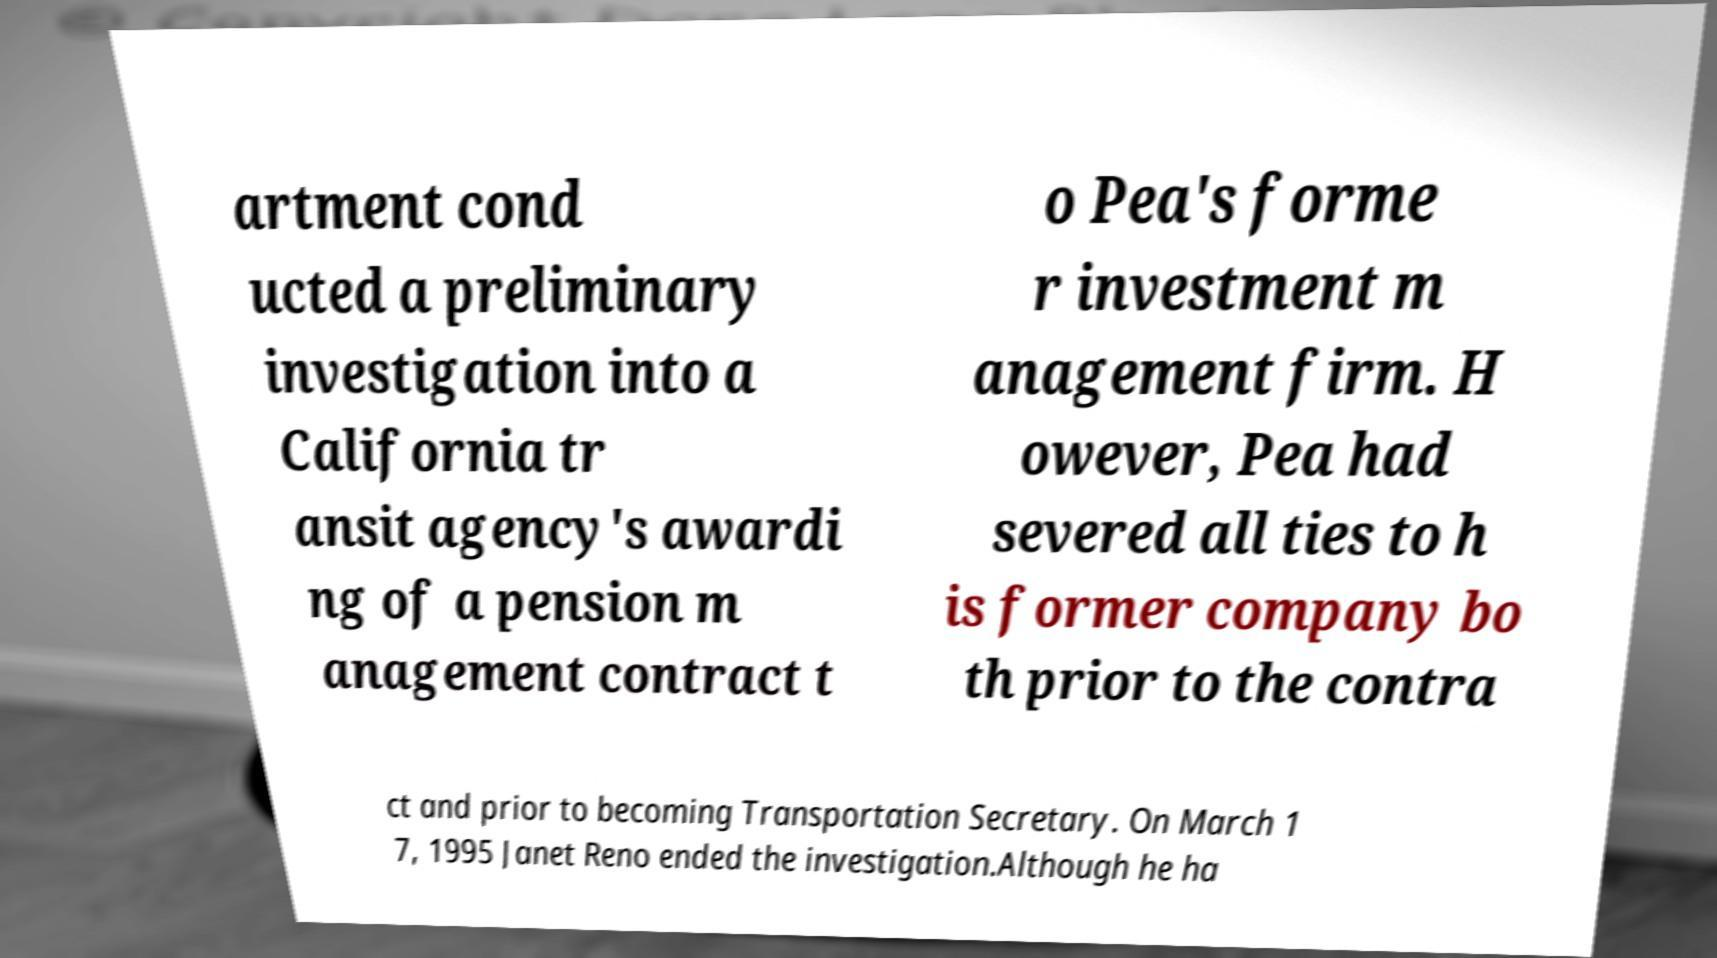What messages or text are displayed in this image? I need them in a readable, typed format. artment cond ucted a preliminary investigation into a California tr ansit agency's awardi ng of a pension m anagement contract t o Pea's forme r investment m anagement firm. H owever, Pea had severed all ties to h is former company bo th prior to the contra ct and prior to becoming Transportation Secretary. On March 1 7, 1995 Janet Reno ended the investigation.Although he ha 